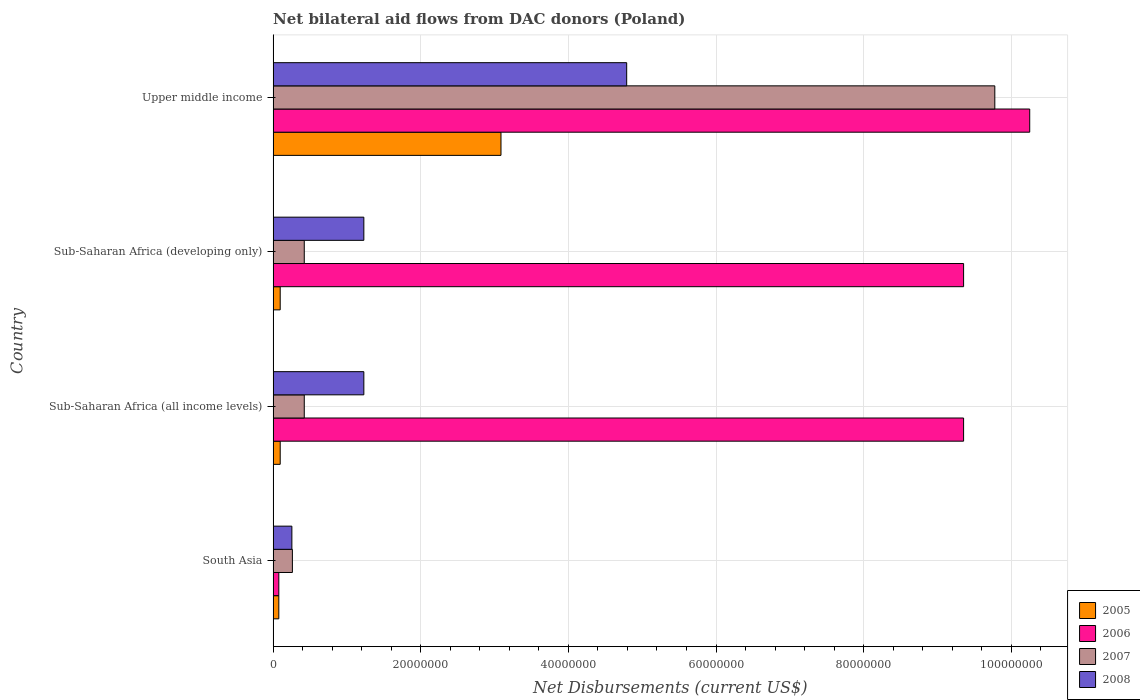How many different coloured bars are there?
Give a very brief answer. 4. Are the number of bars per tick equal to the number of legend labels?
Offer a terse response. Yes. How many bars are there on the 4th tick from the top?
Make the answer very short. 4. What is the label of the 4th group of bars from the top?
Provide a short and direct response. South Asia. What is the net bilateral aid flows in 2008 in Sub-Saharan Africa (developing only)?
Keep it short and to the point. 1.23e+07. Across all countries, what is the maximum net bilateral aid flows in 2005?
Ensure brevity in your answer.  3.09e+07. Across all countries, what is the minimum net bilateral aid flows in 2007?
Offer a terse response. 2.61e+06. In which country was the net bilateral aid flows in 2006 maximum?
Give a very brief answer. Upper middle income. What is the total net bilateral aid flows in 2008 in the graph?
Your response must be concise. 7.50e+07. What is the difference between the net bilateral aid flows in 2006 in South Asia and that in Sub-Saharan Africa (developing only)?
Provide a short and direct response. -9.28e+07. What is the difference between the net bilateral aid flows in 2008 in Sub-Saharan Africa (all income levels) and the net bilateral aid flows in 2005 in Upper middle income?
Keep it short and to the point. -1.86e+07. What is the average net bilateral aid flows in 2006 per country?
Give a very brief answer. 7.26e+07. What is the difference between the net bilateral aid flows in 2007 and net bilateral aid flows in 2008 in South Asia?
Your response must be concise. 7.00e+04. In how many countries, is the net bilateral aid flows in 2007 greater than 28000000 US$?
Keep it short and to the point. 1. What is the ratio of the net bilateral aid flows in 2008 in Sub-Saharan Africa (all income levels) to that in Sub-Saharan Africa (developing only)?
Your response must be concise. 1. Is the difference between the net bilateral aid flows in 2007 in South Asia and Sub-Saharan Africa (developing only) greater than the difference between the net bilateral aid flows in 2008 in South Asia and Sub-Saharan Africa (developing only)?
Make the answer very short. Yes. What is the difference between the highest and the second highest net bilateral aid flows in 2008?
Offer a terse response. 3.56e+07. What is the difference between the highest and the lowest net bilateral aid flows in 2006?
Offer a very short reply. 1.02e+08. What does the 2nd bar from the top in South Asia represents?
Provide a short and direct response. 2007. What does the 1st bar from the bottom in Sub-Saharan Africa (all income levels) represents?
Your answer should be very brief. 2005. How many bars are there?
Provide a succinct answer. 16. How many countries are there in the graph?
Make the answer very short. 4. Does the graph contain any zero values?
Give a very brief answer. No. What is the title of the graph?
Offer a terse response. Net bilateral aid flows from DAC donors (Poland). What is the label or title of the X-axis?
Give a very brief answer. Net Disbursements (current US$). What is the label or title of the Y-axis?
Give a very brief answer. Country. What is the Net Disbursements (current US$) in 2005 in South Asia?
Your answer should be very brief. 7.70e+05. What is the Net Disbursements (current US$) of 2006 in South Asia?
Offer a terse response. 7.70e+05. What is the Net Disbursements (current US$) of 2007 in South Asia?
Make the answer very short. 2.61e+06. What is the Net Disbursements (current US$) in 2008 in South Asia?
Your answer should be very brief. 2.54e+06. What is the Net Disbursements (current US$) of 2005 in Sub-Saharan Africa (all income levels)?
Give a very brief answer. 9.60e+05. What is the Net Disbursements (current US$) of 2006 in Sub-Saharan Africa (all income levels)?
Keep it short and to the point. 9.35e+07. What is the Net Disbursements (current US$) of 2007 in Sub-Saharan Africa (all income levels)?
Your response must be concise. 4.22e+06. What is the Net Disbursements (current US$) in 2008 in Sub-Saharan Africa (all income levels)?
Make the answer very short. 1.23e+07. What is the Net Disbursements (current US$) in 2005 in Sub-Saharan Africa (developing only)?
Offer a terse response. 9.60e+05. What is the Net Disbursements (current US$) in 2006 in Sub-Saharan Africa (developing only)?
Provide a succinct answer. 9.35e+07. What is the Net Disbursements (current US$) in 2007 in Sub-Saharan Africa (developing only)?
Give a very brief answer. 4.22e+06. What is the Net Disbursements (current US$) of 2008 in Sub-Saharan Africa (developing only)?
Offer a terse response. 1.23e+07. What is the Net Disbursements (current US$) of 2005 in Upper middle income?
Keep it short and to the point. 3.09e+07. What is the Net Disbursements (current US$) of 2006 in Upper middle income?
Your response must be concise. 1.02e+08. What is the Net Disbursements (current US$) of 2007 in Upper middle income?
Keep it short and to the point. 9.78e+07. What is the Net Disbursements (current US$) in 2008 in Upper middle income?
Ensure brevity in your answer.  4.79e+07. Across all countries, what is the maximum Net Disbursements (current US$) in 2005?
Give a very brief answer. 3.09e+07. Across all countries, what is the maximum Net Disbursements (current US$) of 2006?
Ensure brevity in your answer.  1.02e+08. Across all countries, what is the maximum Net Disbursements (current US$) of 2007?
Your answer should be compact. 9.78e+07. Across all countries, what is the maximum Net Disbursements (current US$) in 2008?
Offer a terse response. 4.79e+07. Across all countries, what is the minimum Net Disbursements (current US$) in 2005?
Your answer should be very brief. 7.70e+05. Across all countries, what is the minimum Net Disbursements (current US$) in 2006?
Keep it short and to the point. 7.70e+05. Across all countries, what is the minimum Net Disbursements (current US$) in 2007?
Offer a very short reply. 2.61e+06. Across all countries, what is the minimum Net Disbursements (current US$) of 2008?
Your answer should be compact. 2.54e+06. What is the total Net Disbursements (current US$) in 2005 in the graph?
Provide a short and direct response. 3.36e+07. What is the total Net Disbursements (current US$) in 2006 in the graph?
Provide a succinct answer. 2.90e+08. What is the total Net Disbursements (current US$) of 2007 in the graph?
Ensure brevity in your answer.  1.09e+08. What is the total Net Disbursements (current US$) in 2008 in the graph?
Offer a terse response. 7.50e+07. What is the difference between the Net Disbursements (current US$) in 2005 in South Asia and that in Sub-Saharan Africa (all income levels)?
Provide a short and direct response. -1.90e+05. What is the difference between the Net Disbursements (current US$) in 2006 in South Asia and that in Sub-Saharan Africa (all income levels)?
Provide a succinct answer. -9.28e+07. What is the difference between the Net Disbursements (current US$) of 2007 in South Asia and that in Sub-Saharan Africa (all income levels)?
Your answer should be very brief. -1.61e+06. What is the difference between the Net Disbursements (current US$) in 2008 in South Asia and that in Sub-Saharan Africa (all income levels)?
Keep it short and to the point. -9.75e+06. What is the difference between the Net Disbursements (current US$) of 2006 in South Asia and that in Sub-Saharan Africa (developing only)?
Give a very brief answer. -9.28e+07. What is the difference between the Net Disbursements (current US$) in 2007 in South Asia and that in Sub-Saharan Africa (developing only)?
Make the answer very short. -1.61e+06. What is the difference between the Net Disbursements (current US$) in 2008 in South Asia and that in Sub-Saharan Africa (developing only)?
Keep it short and to the point. -9.75e+06. What is the difference between the Net Disbursements (current US$) in 2005 in South Asia and that in Upper middle income?
Your response must be concise. -3.01e+07. What is the difference between the Net Disbursements (current US$) of 2006 in South Asia and that in Upper middle income?
Your answer should be very brief. -1.02e+08. What is the difference between the Net Disbursements (current US$) of 2007 in South Asia and that in Upper middle income?
Ensure brevity in your answer.  -9.52e+07. What is the difference between the Net Disbursements (current US$) in 2008 in South Asia and that in Upper middle income?
Provide a succinct answer. -4.54e+07. What is the difference between the Net Disbursements (current US$) of 2006 in Sub-Saharan Africa (all income levels) and that in Sub-Saharan Africa (developing only)?
Keep it short and to the point. 0. What is the difference between the Net Disbursements (current US$) in 2005 in Sub-Saharan Africa (all income levels) and that in Upper middle income?
Ensure brevity in your answer.  -2.99e+07. What is the difference between the Net Disbursements (current US$) in 2006 in Sub-Saharan Africa (all income levels) and that in Upper middle income?
Offer a terse response. -8.96e+06. What is the difference between the Net Disbursements (current US$) of 2007 in Sub-Saharan Africa (all income levels) and that in Upper middle income?
Ensure brevity in your answer.  -9.36e+07. What is the difference between the Net Disbursements (current US$) of 2008 in Sub-Saharan Africa (all income levels) and that in Upper middle income?
Make the answer very short. -3.56e+07. What is the difference between the Net Disbursements (current US$) of 2005 in Sub-Saharan Africa (developing only) and that in Upper middle income?
Give a very brief answer. -2.99e+07. What is the difference between the Net Disbursements (current US$) in 2006 in Sub-Saharan Africa (developing only) and that in Upper middle income?
Offer a terse response. -8.96e+06. What is the difference between the Net Disbursements (current US$) of 2007 in Sub-Saharan Africa (developing only) and that in Upper middle income?
Make the answer very short. -9.36e+07. What is the difference between the Net Disbursements (current US$) of 2008 in Sub-Saharan Africa (developing only) and that in Upper middle income?
Your answer should be very brief. -3.56e+07. What is the difference between the Net Disbursements (current US$) in 2005 in South Asia and the Net Disbursements (current US$) in 2006 in Sub-Saharan Africa (all income levels)?
Keep it short and to the point. -9.28e+07. What is the difference between the Net Disbursements (current US$) of 2005 in South Asia and the Net Disbursements (current US$) of 2007 in Sub-Saharan Africa (all income levels)?
Your response must be concise. -3.45e+06. What is the difference between the Net Disbursements (current US$) in 2005 in South Asia and the Net Disbursements (current US$) in 2008 in Sub-Saharan Africa (all income levels)?
Make the answer very short. -1.15e+07. What is the difference between the Net Disbursements (current US$) in 2006 in South Asia and the Net Disbursements (current US$) in 2007 in Sub-Saharan Africa (all income levels)?
Provide a short and direct response. -3.45e+06. What is the difference between the Net Disbursements (current US$) of 2006 in South Asia and the Net Disbursements (current US$) of 2008 in Sub-Saharan Africa (all income levels)?
Provide a succinct answer. -1.15e+07. What is the difference between the Net Disbursements (current US$) of 2007 in South Asia and the Net Disbursements (current US$) of 2008 in Sub-Saharan Africa (all income levels)?
Offer a terse response. -9.68e+06. What is the difference between the Net Disbursements (current US$) in 2005 in South Asia and the Net Disbursements (current US$) in 2006 in Sub-Saharan Africa (developing only)?
Give a very brief answer. -9.28e+07. What is the difference between the Net Disbursements (current US$) in 2005 in South Asia and the Net Disbursements (current US$) in 2007 in Sub-Saharan Africa (developing only)?
Your response must be concise. -3.45e+06. What is the difference between the Net Disbursements (current US$) of 2005 in South Asia and the Net Disbursements (current US$) of 2008 in Sub-Saharan Africa (developing only)?
Your response must be concise. -1.15e+07. What is the difference between the Net Disbursements (current US$) in 2006 in South Asia and the Net Disbursements (current US$) in 2007 in Sub-Saharan Africa (developing only)?
Your answer should be compact. -3.45e+06. What is the difference between the Net Disbursements (current US$) of 2006 in South Asia and the Net Disbursements (current US$) of 2008 in Sub-Saharan Africa (developing only)?
Give a very brief answer. -1.15e+07. What is the difference between the Net Disbursements (current US$) in 2007 in South Asia and the Net Disbursements (current US$) in 2008 in Sub-Saharan Africa (developing only)?
Offer a terse response. -9.68e+06. What is the difference between the Net Disbursements (current US$) of 2005 in South Asia and the Net Disbursements (current US$) of 2006 in Upper middle income?
Make the answer very short. -1.02e+08. What is the difference between the Net Disbursements (current US$) in 2005 in South Asia and the Net Disbursements (current US$) in 2007 in Upper middle income?
Offer a terse response. -9.70e+07. What is the difference between the Net Disbursements (current US$) of 2005 in South Asia and the Net Disbursements (current US$) of 2008 in Upper middle income?
Give a very brief answer. -4.71e+07. What is the difference between the Net Disbursements (current US$) in 2006 in South Asia and the Net Disbursements (current US$) in 2007 in Upper middle income?
Your response must be concise. -9.70e+07. What is the difference between the Net Disbursements (current US$) in 2006 in South Asia and the Net Disbursements (current US$) in 2008 in Upper middle income?
Ensure brevity in your answer.  -4.71e+07. What is the difference between the Net Disbursements (current US$) in 2007 in South Asia and the Net Disbursements (current US$) in 2008 in Upper middle income?
Ensure brevity in your answer.  -4.53e+07. What is the difference between the Net Disbursements (current US$) in 2005 in Sub-Saharan Africa (all income levels) and the Net Disbursements (current US$) in 2006 in Sub-Saharan Africa (developing only)?
Your response must be concise. -9.26e+07. What is the difference between the Net Disbursements (current US$) in 2005 in Sub-Saharan Africa (all income levels) and the Net Disbursements (current US$) in 2007 in Sub-Saharan Africa (developing only)?
Provide a short and direct response. -3.26e+06. What is the difference between the Net Disbursements (current US$) of 2005 in Sub-Saharan Africa (all income levels) and the Net Disbursements (current US$) of 2008 in Sub-Saharan Africa (developing only)?
Offer a very short reply. -1.13e+07. What is the difference between the Net Disbursements (current US$) of 2006 in Sub-Saharan Africa (all income levels) and the Net Disbursements (current US$) of 2007 in Sub-Saharan Africa (developing only)?
Offer a very short reply. 8.93e+07. What is the difference between the Net Disbursements (current US$) of 2006 in Sub-Saharan Africa (all income levels) and the Net Disbursements (current US$) of 2008 in Sub-Saharan Africa (developing only)?
Keep it short and to the point. 8.12e+07. What is the difference between the Net Disbursements (current US$) of 2007 in Sub-Saharan Africa (all income levels) and the Net Disbursements (current US$) of 2008 in Sub-Saharan Africa (developing only)?
Ensure brevity in your answer.  -8.07e+06. What is the difference between the Net Disbursements (current US$) in 2005 in Sub-Saharan Africa (all income levels) and the Net Disbursements (current US$) in 2006 in Upper middle income?
Provide a short and direct response. -1.02e+08. What is the difference between the Net Disbursements (current US$) of 2005 in Sub-Saharan Africa (all income levels) and the Net Disbursements (current US$) of 2007 in Upper middle income?
Your answer should be very brief. -9.68e+07. What is the difference between the Net Disbursements (current US$) in 2005 in Sub-Saharan Africa (all income levels) and the Net Disbursements (current US$) in 2008 in Upper middle income?
Your response must be concise. -4.69e+07. What is the difference between the Net Disbursements (current US$) in 2006 in Sub-Saharan Africa (all income levels) and the Net Disbursements (current US$) in 2007 in Upper middle income?
Ensure brevity in your answer.  -4.23e+06. What is the difference between the Net Disbursements (current US$) of 2006 in Sub-Saharan Africa (all income levels) and the Net Disbursements (current US$) of 2008 in Upper middle income?
Make the answer very short. 4.56e+07. What is the difference between the Net Disbursements (current US$) of 2007 in Sub-Saharan Africa (all income levels) and the Net Disbursements (current US$) of 2008 in Upper middle income?
Your answer should be compact. -4.37e+07. What is the difference between the Net Disbursements (current US$) of 2005 in Sub-Saharan Africa (developing only) and the Net Disbursements (current US$) of 2006 in Upper middle income?
Provide a short and direct response. -1.02e+08. What is the difference between the Net Disbursements (current US$) in 2005 in Sub-Saharan Africa (developing only) and the Net Disbursements (current US$) in 2007 in Upper middle income?
Ensure brevity in your answer.  -9.68e+07. What is the difference between the Net Disbursements (current US$) in 2005 in Sub-Saharan Africa (developing only) and the Net Disbursements (current US$) in 2008 in Upper middle income?
Offer a terse response. -4.69e+07. What is the difference between the Net Disbursements (current US$) of 2006 in Sub-Saharan Africa (developing only) and the Net Disbursements (current US$) of 2007 in Upper middle income?
Ensure brevity in your answer.  -4.23e+06. What is the difference between the Net Disbursements (current US$) of 2006 in Sub-Saharan Africa (developing only) and the Net Disbursements (current US$) of 2008 in Upper middle income?
Offer a very short reply. 4.56e+07. What is the difference between the Net Disbursements (current US$) of 2007 in Sub-Saharan Africa (developing only) and the Net Disbursements (current US$) of 2008 in Upper middle income?
Provide a short and direct response. -4.37e+07. What is the average Net Disbursements (current US$) of 2005 per country?
Your answer should be very brief. 8.39e+06. What is the average Net Disbursements (current US$) in 2006 per country?
Your answer should be compact. 7.26e+07. What is the average Net Disbursements (current US$) in 2007 per country?
Keep it short and to the point. 2.72e+07. What is the average Net Disbursements (current US$) of 2008 per country?
Make the answer very short. 1.88e+07. What is the difference between the Net Disbursements (current US$) of 2005 and Net Disbursements (current US$) of 2007 in South Asia?
Provide a succinct answer. -1.84e+06. What is the difference between the Net Disbursements (current US$) of 2005 and Net Disbursements (current US$) of 2008 in South Asia?
Your response must be concise. -1.77e+06. What is the difference between the Net Disbursements (current US$) of 2006 and Net Disbursements (current US$) of 2007 in South Asia?
Offer a terse response. -1.84e+06. What is the difference between the Net Disbursements (current US$) in 2006 and Net Disbursements (current US$) in 2008 in South Asia?
Your answer should be compact. -1.77e+06. What is the difference between the Net Disbursements (current US$) of 2005 and Net Disbursements (current US$) of 2006 in Sub-Saharan Africa (all income levels)?
Your answer should be compact. -9.26e+07. What is the difference between the Net Disbursements (current US$) of 2005 and Net Disbursements (current US$) of 2007 in Sub-Saharan Africa (all income levels)?
Make the answer very short. -3.26e+06. What is the difference between the Net Disbursements (current US$) of 2005 and Net Disbursements (current US$) of 2008 in Sub-Saharan Africa (all income levels)?
Your response must be concise. -1.13e+07. What is the difference between the Net Disbursements (current US$) in 2006 and Net Disbursements (current US$) in 2007 in Sub-Saharan Africa (all income levels)?
Your response must be concise. 8.93e+07. What is the difference between the Net Disbursements (current US$) of 2006 and Net Disbursements (current US$) of 2008 in Sub-Saharan Africa (all income levels)?
Make the answer very short. 8.12e+07. What is the difference between the Net Disbursements (current US$) in 2007 and Net Disbursements (current US$) in 2008 in Sub-Saharan Africa (all income levels)?
Your response must be concise. -8.07e+06. What is the difference between the Net Disbursements (current US$) of 2005 and Net Disbursements (current US$) of 2006 in Sub-Saharan Africa (developing only)?
Provide a short and direct response. -9.26e+07. What is the difference between the Net Disbursements (current US$) of 2005 and Net Disbursements (current US$) of 2007 in Sub-Saharan Africa (developing only)?
Provide a succinct answer. -3.26e+06. What is the difference between the Net Disbursements (current US$) in 2005 and Net Disbursements (current US$) in 2008 in Sub-Saharan Africa (developing only)?
Your response must be concise. -1.13e+07. What is the difference between the Net Disbursements (current US$) in 2006 and Net Disbursements (current US$) in 2007 in Sub-Saharan Africa (developing only)?
Offer a terse response. 8.93e+07. What is the difference between the Net Disbursements (current US$) of 2006 and Net Disbursements (current US$) of 2008 in Sub-Saharan Africa (developing only)?
Provide a short and direct response. 8.12e+07. What is the difference between the Net Disbursements (current US$) in 2007 and Net Disbursements (current US$) in 2008 in Sub-Saharan Africa (developing only)?
Offer a very short reply. -8.07e+06. What is the difference between the Net Disbursements (current US$) of 2005 and Net Disbursements (current US$) of 2006 in Upper middle income?
Your answer should be compact. -7.16e+07. What is the difference between the Net Disbursements (current US$) of 2005 and Net Disbursements (current US$) of 2007 in Upper middle income?
Your response must be concise. -6.69e+07. What is the difference between the Net Disbursements (current US$) of 2005 and Net Disbursements (current US$) of 2008 in Upper middle income?
Keep it short and to the point. -1.70e+07. What is the difference between the Net Disbursements (current US$) of 2006 and Net Disbursements (current US$) of 2007 in Upper middle income?
Keep it short and to the point. 4.73e+06. What is the difference between the Net Disbursements (current US$) in 2006 and Net Disbursements (current US$) in 2008 in Upper middle income?
Your response must be concise. 5.46e+07. What is the difference between the Net Disbursements (current US$) in 2007 and Net Disbursements (current US$) in 2008 in Upper middle income?
Provide a succinct answer. 4.99e+07. What is the ratio of the Net Disbursements (current US$) of 2005 in South Asia to that in Sub-Saharan Africa (all income levels)?
Offer a terse response. 0.8. What is the ratio of the Net Disbursements (current US$) in 2006 in South Asia to that in Sub-Saharan Africa (all income levels)?
Ensure brevity in your answer.  0.01. What is the ratio of the Net Disbursements (current US$) in 2007 in South Asia to that in Sub-Saharan Africa (all income levels)?
Your answer should be compact. 0.62. What is the ratio of the Net Disbursements (current US$) of 2008 in South Asia to that in Sub-Saharan Africa (all income levels)?
Provide a short and direct response. 0.21. What is the ratio of the Net Disbursements (current US$) in 2005 in South Asia to that in Sub-Saharan Africa (developing only)?
Ensure brevity in your answer.  0.8. What is the ratio of the Net Disbursements (current US$) in 2006 in South Asia to that in Sub-Saharan Africa (developing only)?
Keep it short and to the point. 0.01. What is the ratio of the Net Disbursements (current US$) of 2007 in South Asia to that in Sub-Saharan Africa (developing only)?
Give a very brief answer. 0.62. What is the ratio of the Net Disbursements (current US$) in 2008 in South Asia to that in Sub-Saharan Africa (developing only)?
Your answer should be compact. 0.21. What is the ratio of the Net Disbursements (current US$) in 2005 in South Asia to that in Upper middle income?
Offer a very short reply. 0.02. What is the ratio of the Net Disbursements (current US$) in 2006 in South Asia to that in Upper middle income?
Your answer should be compact. 0.01. What is the ratio of the Net Disbursements (current US$) of 2007 in South Asia to that in Upper middle income?
Provide a short and direct response. 0.03. What is the ratio of the Net Disbursements (current US$) of 2008 in South Asia to that in Upper middle income?
Provide a succinct answer. 0.05. What is the ratio of the Net Disbursements (current US$) of 2005 in Sub-Saharan Africa (all income levels) to that in Sub-Saharan Africa (developing only)?
Offer a very short reply. 1. What is the ratio of the Net Disbursements (current US$) of 2006 in Sub-Saharan Africa (all income levels) to that in Sub-Saharan Africa (developing only)?
Provide a succinct answer. 1. What is the ratio of the Net Disbursements (current US$) in 2005 in Sub-Saharan Africa (all income levels) to that in Upper middle income?
Give a very brief answer. 0.03. What is the ratio of the Net Disbursements (current US$) of 2006 in Sub-Saharan Africa (all income levels) to that in Upper middle income?
Give a very brief answer. 0.91. What is the ratio of the Net Disbursements (current US$) in 2007 in Sub-Saharan Africa (all income levels) to that in Upper middle income?
Make the answer very short. 0.04. What is the ratio of the Net Disbursements (current US$) in 2008 in Sub-Saharan Africa (all income levels) to that in Upper middle income?
Provide a short and direct response. 0.26. What is the ratio of the Net Disbursements (current US$) in 2005 in Sub-Saharan Africa (developing only) to that in Upper middle income?
Your response must be concise. 0.03. What is the ratio of the Net Disbursements (current US$) in 2006 in Sub-Saharan Africa (developing only) to that in Upper middle income?
Your answer should be compact. 0.91. What is the ratio of the Net Disbursements (current US$) in 2007 in Sub-Saharan Africa (developing only) to that in Upper middle income?
Keep it short and to the point. 0.04. What is the ratio of the Net Disbursements (current US$) of 2008 in Sub-Saharan Africa (developing only) to that in Upper middle income?
Provide a succinct answer. 0.26. What is the difference between the highest and the second highest Net Disbursements (current US$) of 2005?
Provide a short and direct response. 2.99e+07. What is the difference between the highest and the second highest Net Disbursements (current US$) of 2006?
Keep it short and to the point. 8.96e+06. What is the difference between the highest and the second highest Net Disbursements (current US$) in 2007?
Provide a succinct answer. 9.36e+07. What is the difference between the highest and the second highest Net Disbursements (current US$) of 2008?
Offer a very short reply. 3.56e+07. What is the difference between the highest and the lowest Net Disbursements (current US$) in 2005?
Give a very brief answer. 3.01e+07. What is the difference between the highest and the lowest Net Disbursements (current US$) in 2006?
Your answer should be compact. 1.02e+08. What is the difference between the highest and the lowest Net Disbursements (current US$) of 2007?
Your response must be concise. 9.52e+07. What is the difference between the highest and the lowest Net Disbursements (current US$) of 2008?
Provide a short and direct response. 4.54e+07. 